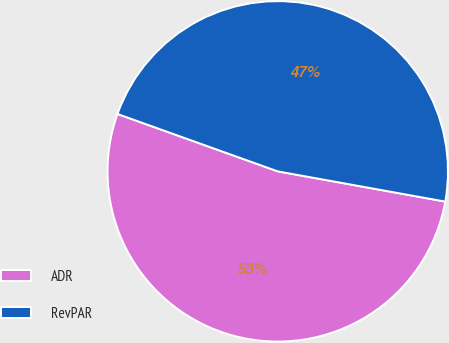<chart> <loc_0><loc_0><loc_500><loc_500><pie_chart><fcel>ADR<fcel>RevPAR<nl><fcel>52.63%<fcel>47.37%<nl></chart> 